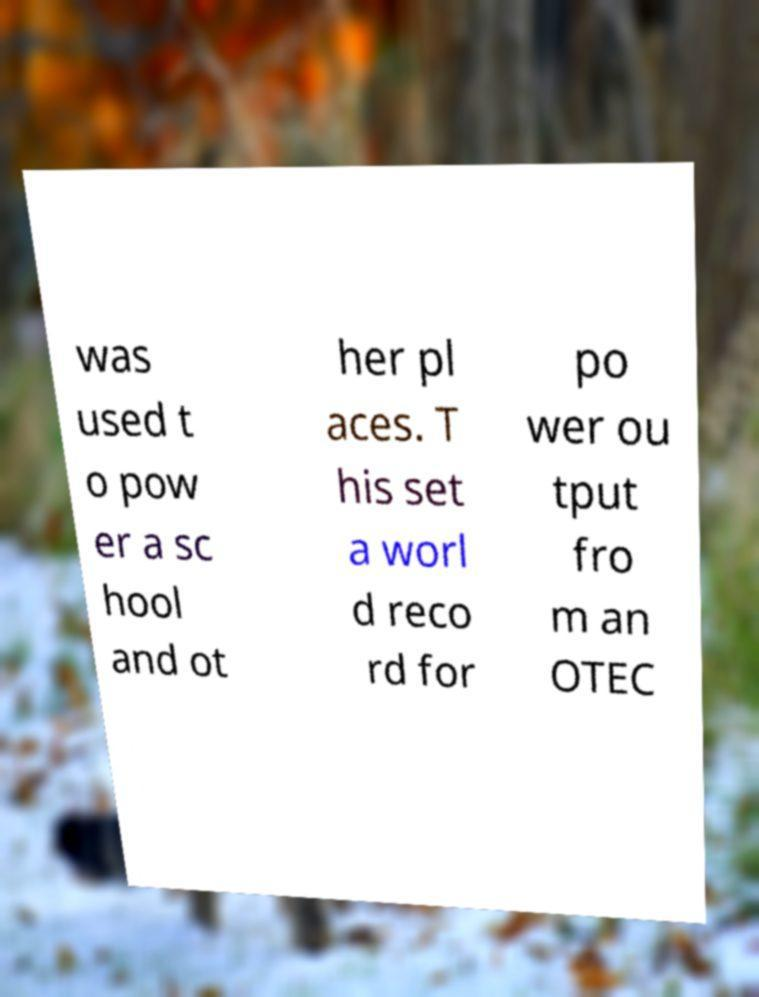For documentation purposes, I need the text within this image transcribed. Could you provide that? was used t o pow er a sc hool and ot her pl aces. T his set a worl d reco rd for po wer ou tput fro m an OTEC 